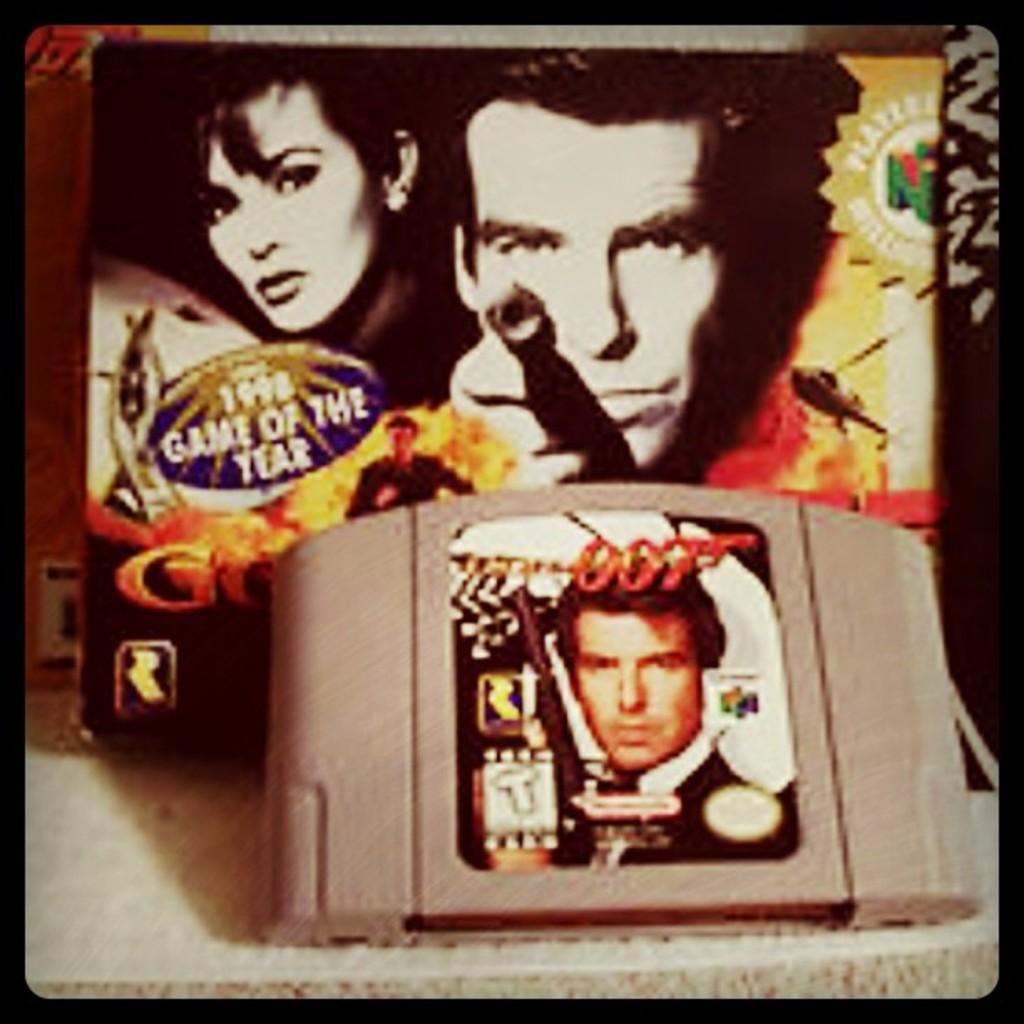Describe this image in one or two sentences. It is an edited image, there is a gadget with some poster on it and behind that gadget there is another object with the pictures of two people and some text. 